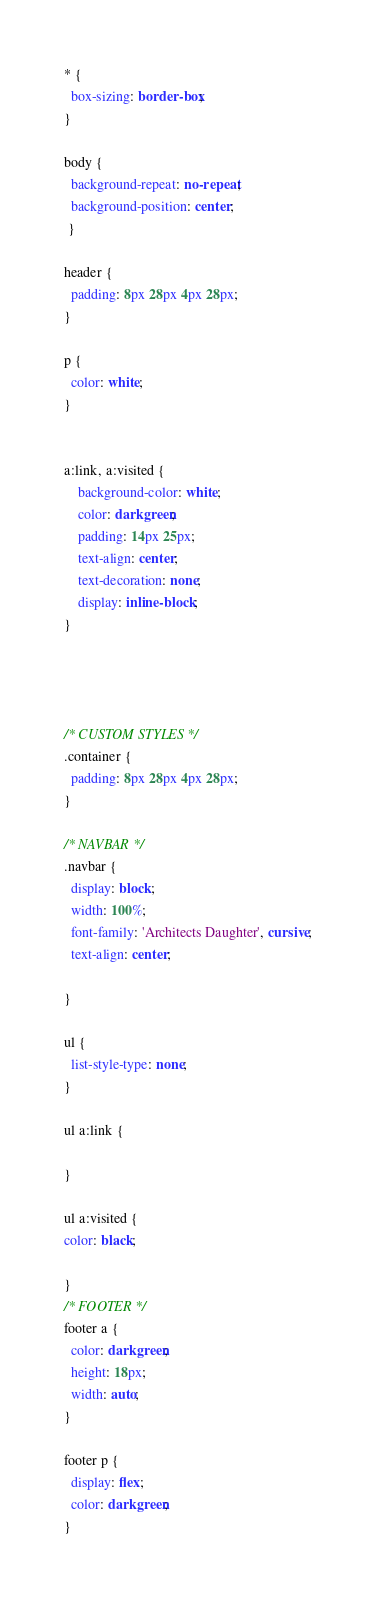<code> <loc_0><loc_0><loc_500><loc_500><_CSS_>
* {
  box-sizing: border-box;
}

body {
  background-repeat: no-repeat;
  background-position: center;
 }

header {
  padding: 8px 28px 4px 28px;
}

p {
  color: white;
}


a:link, a:visited {
    background-color: white;
    color: darkgreen;
    padding: 14px 25px;
    text-align: center;
    text-decoration: none;
    display: inline-block;
}




/* CUSTOM STYLES */
.container {
  padding: 8px 28px 4px 28px;
}

/* NAVBAR */
.navbar {
  display: block;
  width: 100%;
  font-family: 'Architects Daughter', cursive;
  text-align: center;

}

ul {
  list-style-type: none;
}

ul a:link {

}

ul a:visited {
color: black;

}
/* FOOTER */
footer a {
  color: darkgreen;
  height: 18px;
  width: auto;
}

footer p {
  display: flex;
  color: darkgreen;
}
</code> 